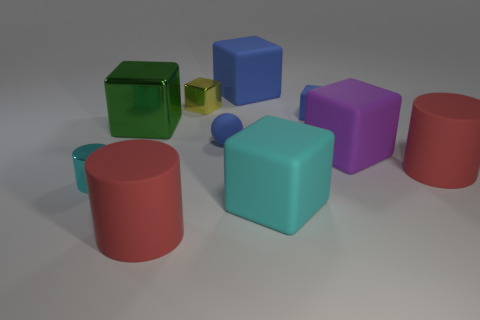Do the red object right of the matte ball and the green thing have the same material?
Keep it short and to the point. No. There is a large thing that is to the left of the yellow shiny thing and behind the big cyan matte cube; what shape is it?
Provide a short and direct response. Cube. Is there a small yellow metallic thing right of the cyan thing on the left side of the rubber sphere?
Offer a terse response. Yes. How many other things are made of the same material as the green object?
Your answer should be compact. 2. There is a red thing to the left of the tiny shiny cube; is it the same shape as the tiny metal object that is on the left side of the big green metal object?
Make the answer very short. Yes. Is the material of the cyan cylinder the same as the big cyan object?
Offer a terse response. No. There is a cyan metal object that is in front of the large red matte cylinder that is behind the red matte object that is left of the purple object; how big is it?
Offer a terse response. Small. How many other objects are there of the same color as the small rubber block?
Provide a succinct answer. 2. There is a cyan metal thing that is the same size as the rubber sphere; what shape is it?
Offer a very short reply. Cylinder. What number of small objects are purple things or green shiny blocks?
Your answer should be very brief. 0. 